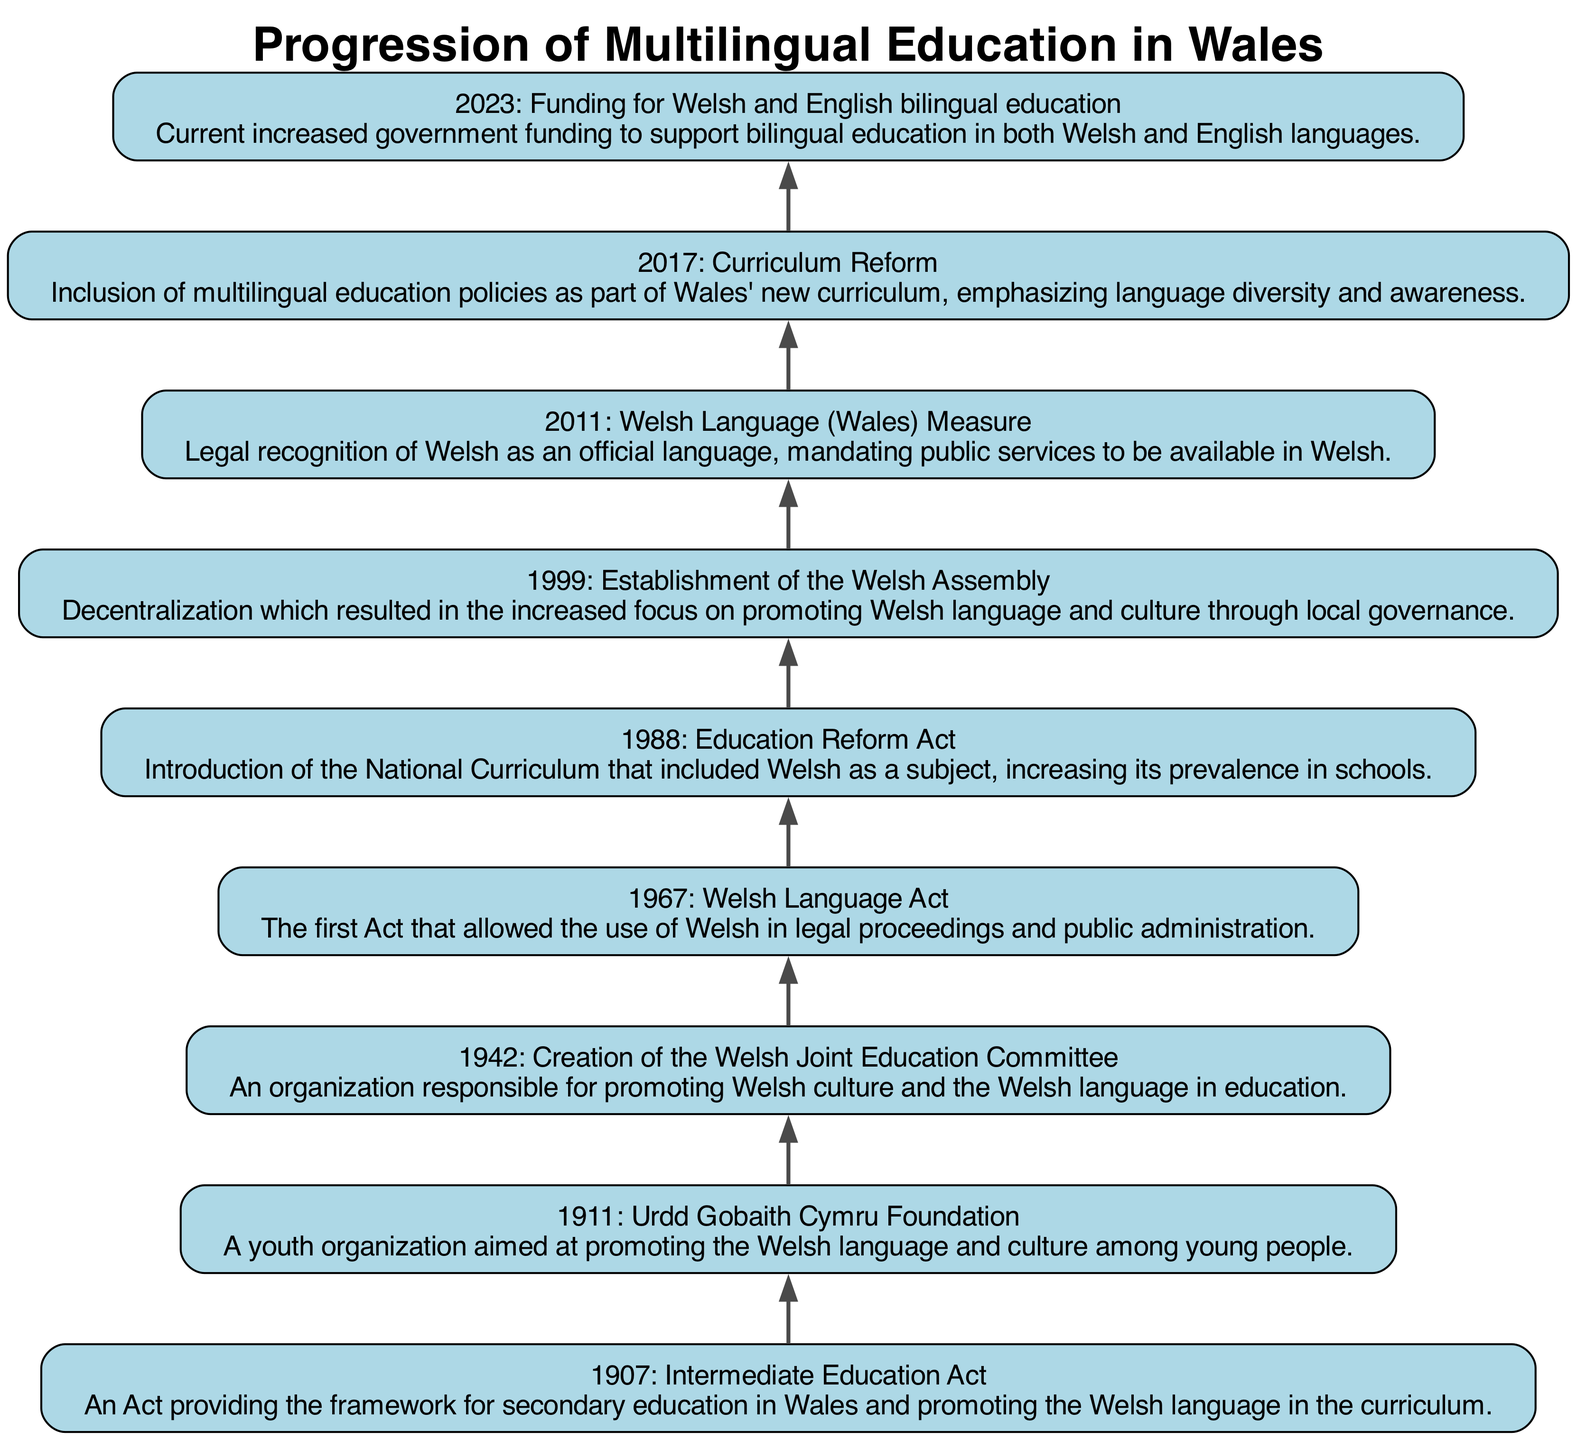what is the most recent milestone in bilingual education in Wales? The diagram lays out a timeline with various milestones. The most recent entry at level 1 is "2023: Funding for Welsh and English bilingual education," which indicates the latest development in the education system.
Answer: 2023: Funding for Welsh and English bilingual education how many historical milestones are shown in the diagram? The diagram contains nine nodes, each representing a historical milestone in the progression of multilingual education in Wales. Counting these nodes gives us the total number of milestones.
Answer: 9 which policy established the Welsh language as an official language? The node at level 3 states "2011: Welsh Language (Wales) Measure," which indicates that this policy provided legal recognition for the Welsh language. This is the direct answer to which policy established its official status.
Answer: 2011: Welsh Language (Wales) Measure what was the significance of the 1999 establishment of the Welsh Assembly? The 1999 node states "Establishment of the Welsh Assembly," and in the details mentions it resulted in "the increased focus on promoting Welsh language and culture through local governance." Thus, the significance lies in its contribution to elevating the Welsh language's importance.
Answer: Increased focus on promoting Welsh language and culture which event led to the introduction of Welsh in the National Curriculum? Referring to the node at level 5, "1988: Education Reform Act" mentions the introduction of the National Curriculum that included Welsh as a subject. This event led to the promotion of Welsh in educational settings.
Answer: 1988: Education Reform Act what precedes the 2017 curriculum reform in the timeline? The flow of the diagram shows that the node directly below the 2017 reform (level 2) is "2011: Welsh Language (Wales) Measure" at level 3. This indicates that the Welsh language measure came prior to the curriculum reform.
Answer: 2011: Welsh Language (Wales) Measure what connection does the 1967 Welsh Language Act have with the establishment of bilingual education? The diagram shows that the "1967: Welsh Language Act" provides foundational legal recognition for the Welsh language, which creates a necessary backdrop for the later developments in bilingual education within the broader context of Welsh culture and identity.
Answer: Provides foundational legal recognition for Welsh language which organization was created in 1942 to promote Welsh culture in education? According to the node at level 7, "1942: Creation of the Welsh Joint Education Committee" is noted as the organization dedicated to promoting Welsh culture and language education. This directly answers the question.
Answer: 1942: Creation of the Welsh Joint Education Committee 